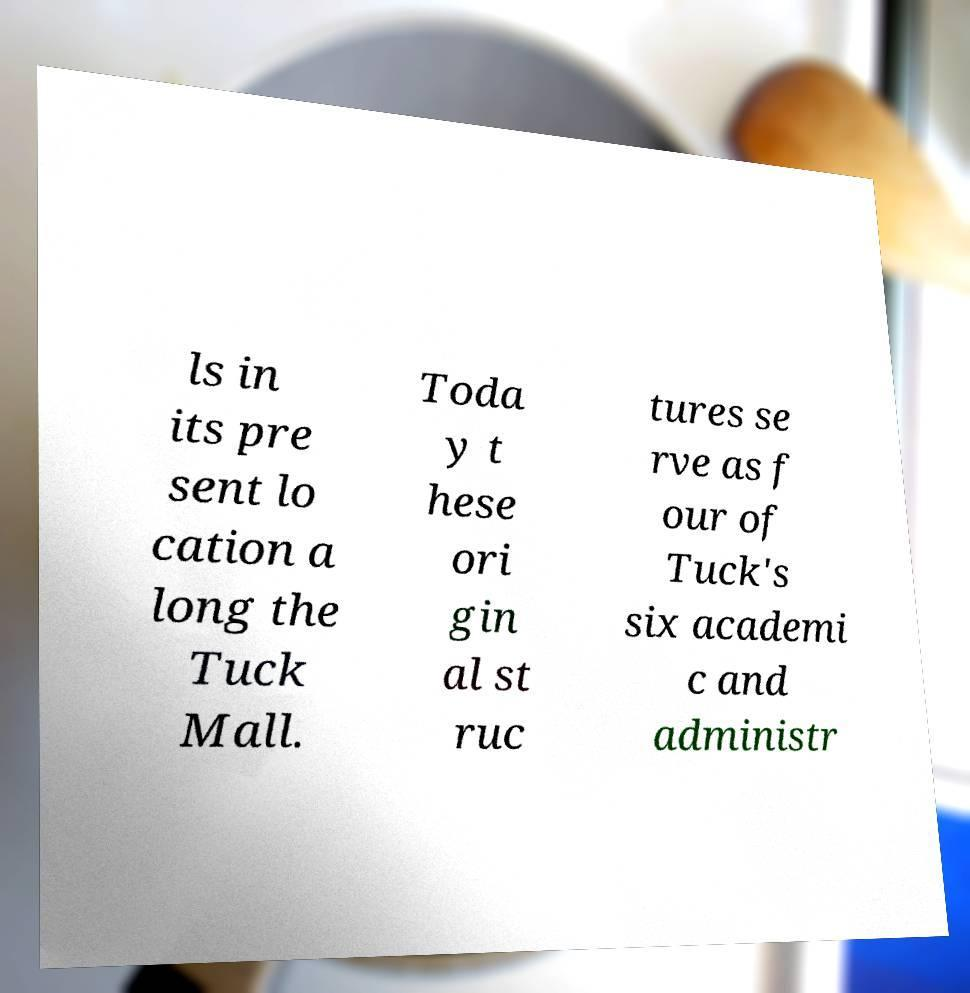Could you assist in decoding the text presented in this image and type it out clearly? ls in its pre sent lo cation a long the Tuck Mall. Toda y t hese ori gin al st ruc tures se rve as f our of Tuck's six academi c and administr 